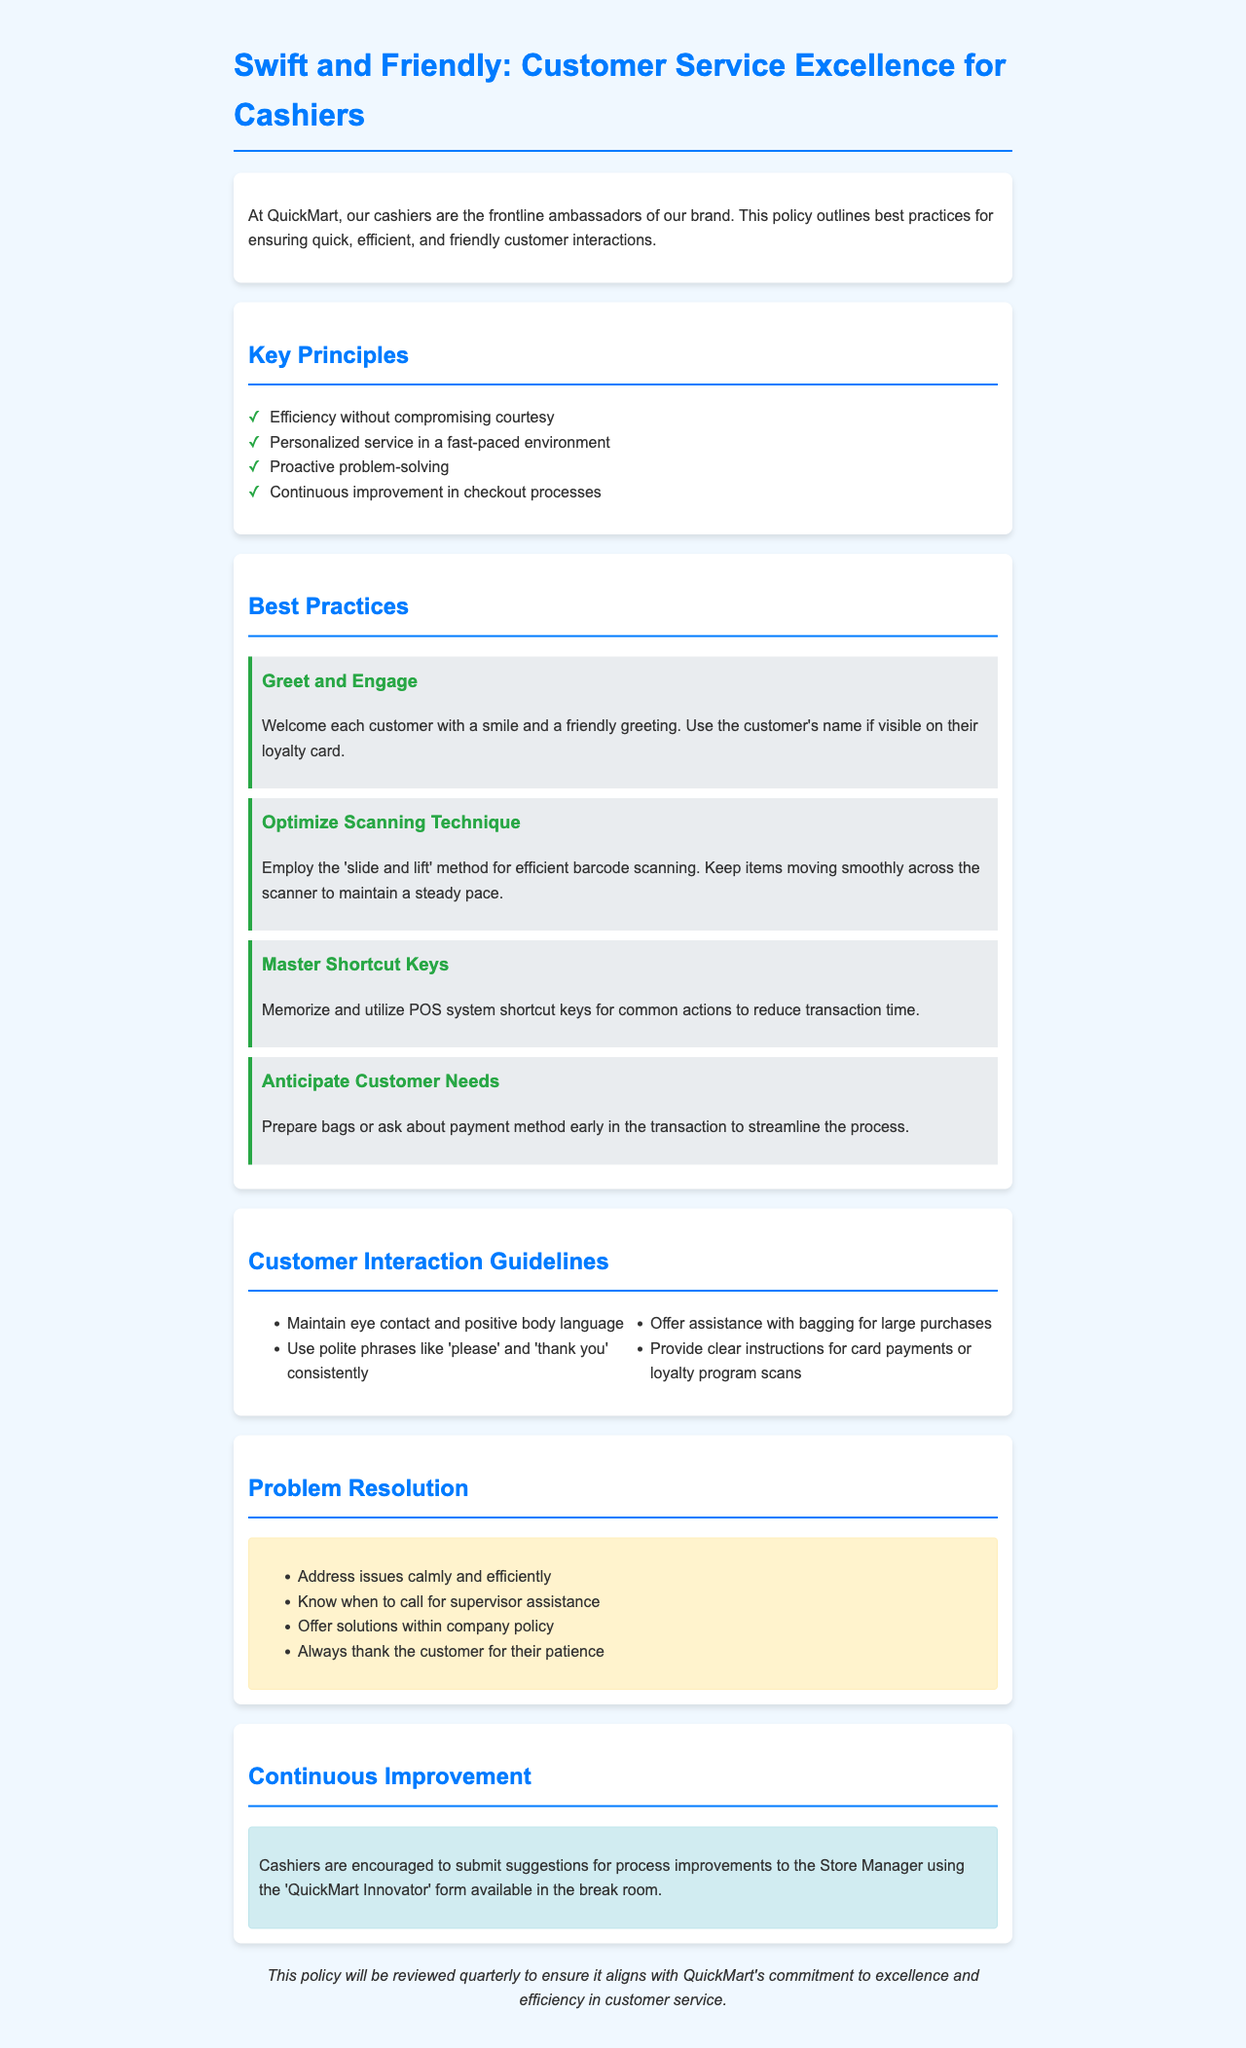what is the title of the policy document? The title is located in the header section of the document.
Answer: Swift and Friendly: Customer Service Excellence for Cashiers how many key principles are listed in the document? The number of principles is found in the Key Principles section.
Answer: 4 what is the first best practice mentioned? The first best practice is stated in the Best Practices section.
Answer: Greet and Engage which method is recommended for efficient barcode scanning? The recommended method is described in the Optimize Scanning Technique section.
Answer: slide and lift what should cashiers maintain during customer interactions? The interaction guidelines mention a specific behavior that should be maintained.
Answer: eye contact what is one action cashiers should take to prepare for customer needs? The anticipation of customer needs includes a specific prep action mentioned in the Best Practices section.
Answer: Prepare bags how often will this policy be reviewed? The review frequency is stated at the end of the document.
Answer: quarterly what type of form can cashiers use to submit process improvement suggestions? The specific name of the form is mentioned in the Continuous Improvement section.
Answer: QuickMart Innovator what should cashiers do when addressing issues? This action is specified in the Problem Resolution section.
Answer: Address issues calmly 